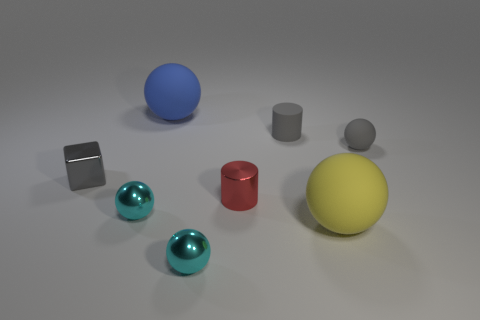Is the cylinder in front of the small gray cube made of the same material as the large blue thing? No, the cylinder in front of the small gray cube appears to have a matte finish and is likely made of a different material than the large blue sphere, which has a glossy surface suggesting a different texture and reflective quality. 